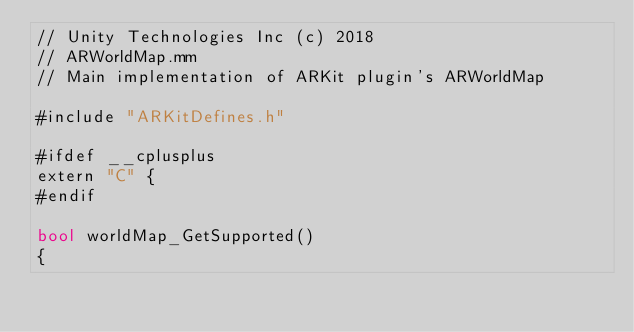<code> <loc_0><loc_0><loc_500><loc_500><_ObjectiveC_>// Unity Technologies Inc (c) 2018
// ARWorldMap.mm
// Main implementation of ARKit plugin's ARWorldMap

#include "ARKitDefines.h"

#ifdef __cplusplus
extern "C" {
#endif
    
bool worldMap_GetSupported()
{</code> 